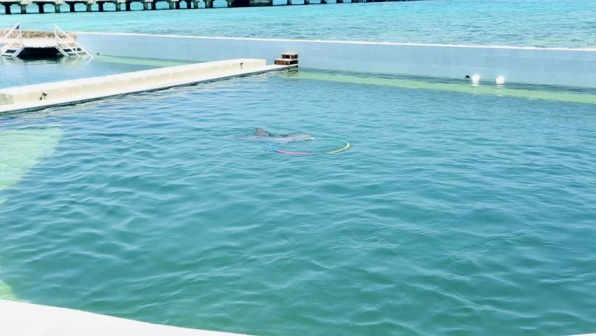What could be a magical scenario involving this image? Imagine if, under the light of a full moon, the dolphin in this image gained the ability to grant wishes. Visitors who came to the pier at night could whisper their deepest desires to the dolphin, who would then swim to a secret underwater cave lined with luminescent corals and magical sea creatures. There, the dolphin would communicate with the ancient spirits of the ocean, asking them to grant these wishes. In return, the spirits would ensure the waters remained pure and the marine life thrived. This magical bond between the dolphin and the visitors would become a legendary tale, attracting people from around the world to experience the enchantment of this unique place. 